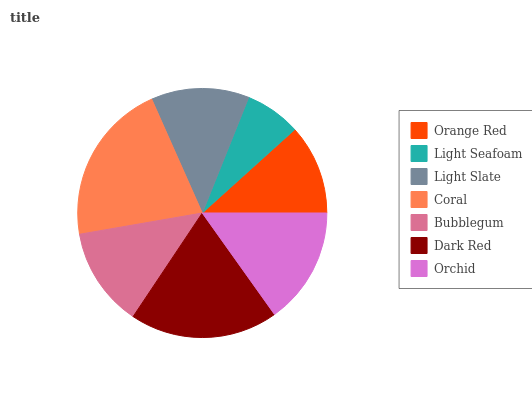Is Light Seafoam the minimum?
Answer yes or no. Yes. Is Coral the maximum?
Answer yes or no. Yes. Is Light Slate the minimum?
Answer yes or no. No. Is Light Slate the maximum?
Answer yes or no. No. Is Light Slate greater than Light Seafoam?
Answer yes or no. Yes. Is Light Seafoam less than Light Slate?
Answer yes or no. Yes. Is Light Seafoam greater than Light Slate?
Answer yes or no. No. Is Light Slate less than Light Seafoam?
Answer yes or no. No. Is Bubblegum the high median?
Answer yes or no. Yes. Is Bubblegum the low median?
Answer yes or no. Yes. Is Orange Red the high median?
Answer yes or no. No. Is Dark Red the low median?
Answer yes or no. No. 